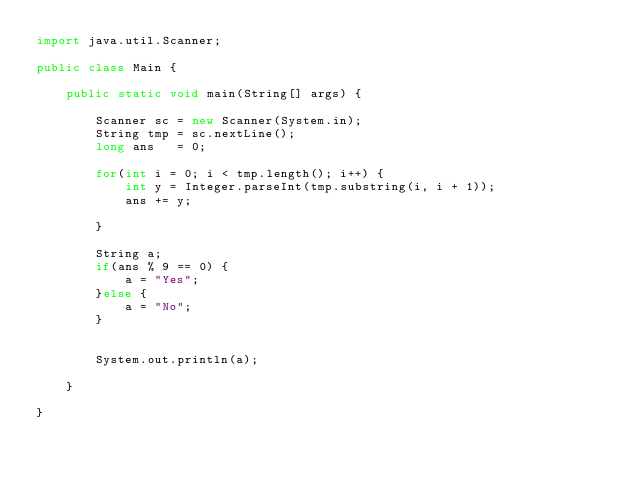Convert code to text. <code><loc_0><loc_0><loc_500><loc_500><_Java_>import java.util.Scanner;

public class Main {

	public static void main(String[] args) {

		Scanner sc = new Scanner(System.in);
		String tmp = sc.nextLine();
		long ans   = 0;

		for(int i = 0; i < tmp.length(); i++) {
			int y = Integer.parseInt(tmp.substring(i, i + 1));
			ans += y;

		}

		String a;
		if(ans % 9 == 0) {
			a = "Yes";
		}else {
			a = "No";
		}


		System.out.println(a);

	}

}
</code> 